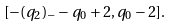<formula> <loc_0><loc_0><loc_500><loc_500>[ - ( q _ { 2 } ) _ { - } - q _ { 0 } + 2 , q _ { 0 } - 2 ] .</formula> 